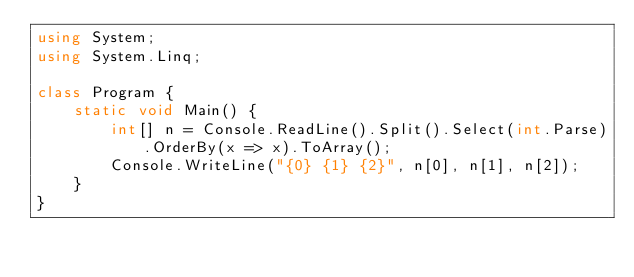<code> <loc_0><loc_0><loc_500><loc_500><_C#_>using System;
using System.Linq;

class Program {
    static void Main() {
        int[] n = Console.ReadLine().Split().Select(int.Parse).OrderBy(x => x).ToArray();
        Console.WriteLine("{0} {1} {2}", n[0], n[1], n[2]);
    }
}
</code> 